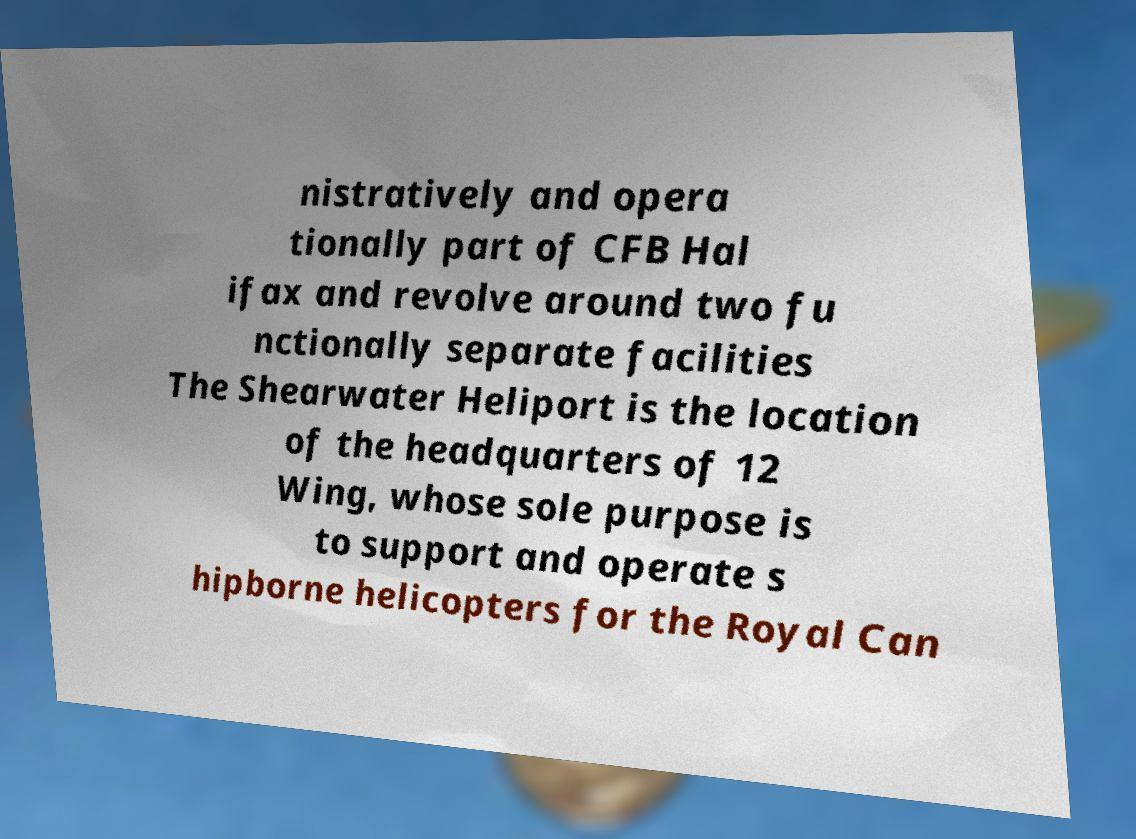There's text embedded in this image that I need extracted. Can you transcribe it verbatim? nistratively and opera tionally part of CFB Hal ifax and revolve around two fu nctionally separate facilities The Shearwater Heliport is the location of the headquarters of 12 Wing, whose sole purpose is to support and operate s hipborne helicopters for the Royal Can 